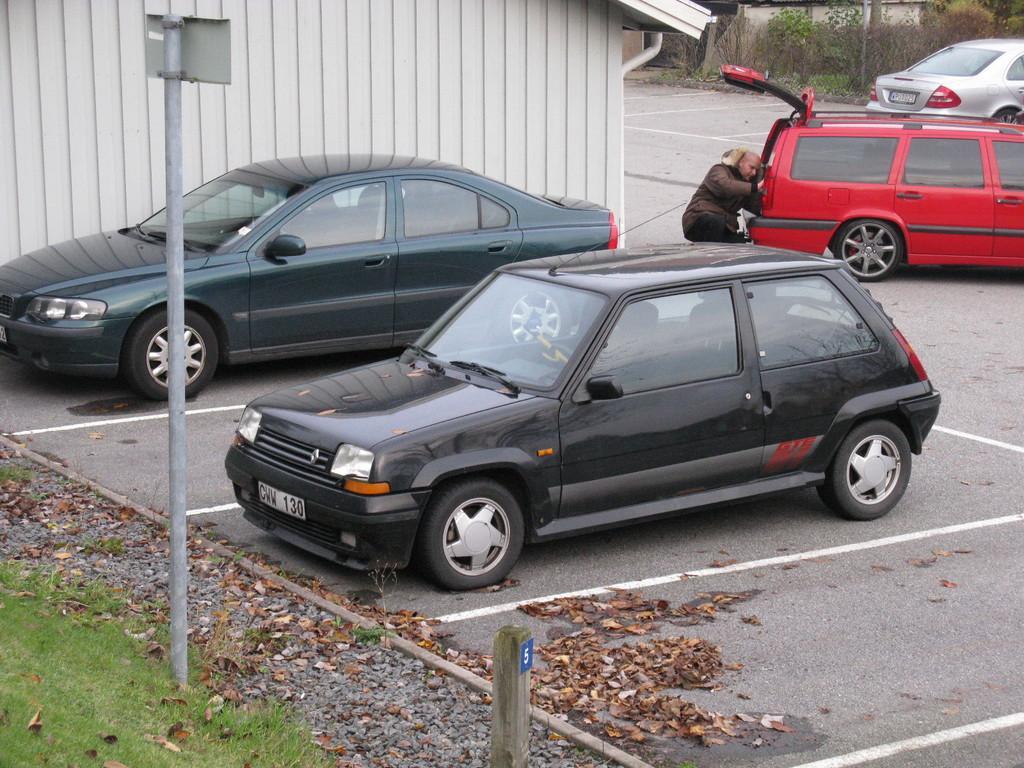Can you describe this image briefly? In the center of the image, we can see vehicles and a person on the road and in the background, there are sheds, trees and poles. At the bottom, there is ground and there are leaves. 